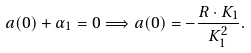<formula> <loc_0><loc_0><loc_500><loc_500>a ( 0 ) + \alpha _ { 1 } = 0 \Longrightarrow a ( 0 ) = - \frac { R \cdot K _ { 1 } } { K _ { 1 } ^ { 2 } } .</formula> 